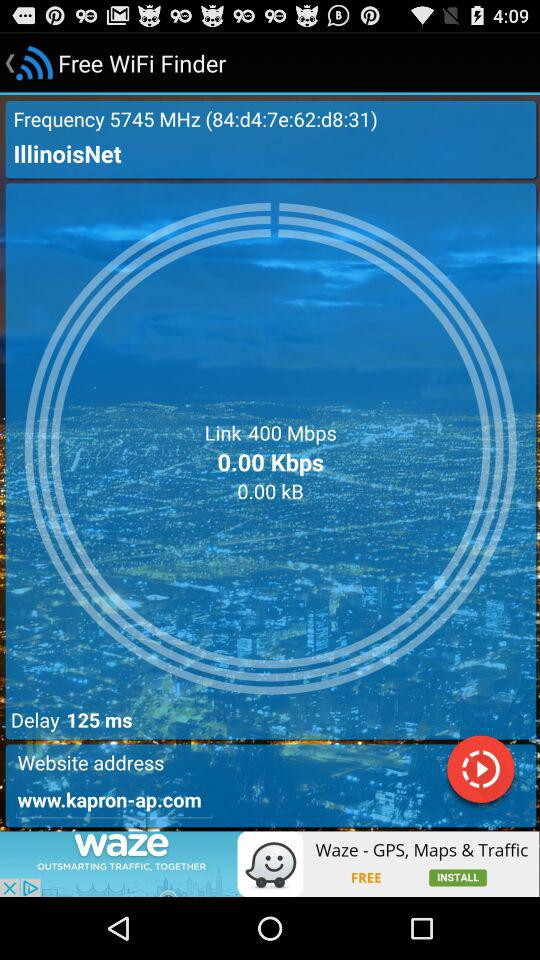How much delay is given on the screen? The given delay is 125 ms. 